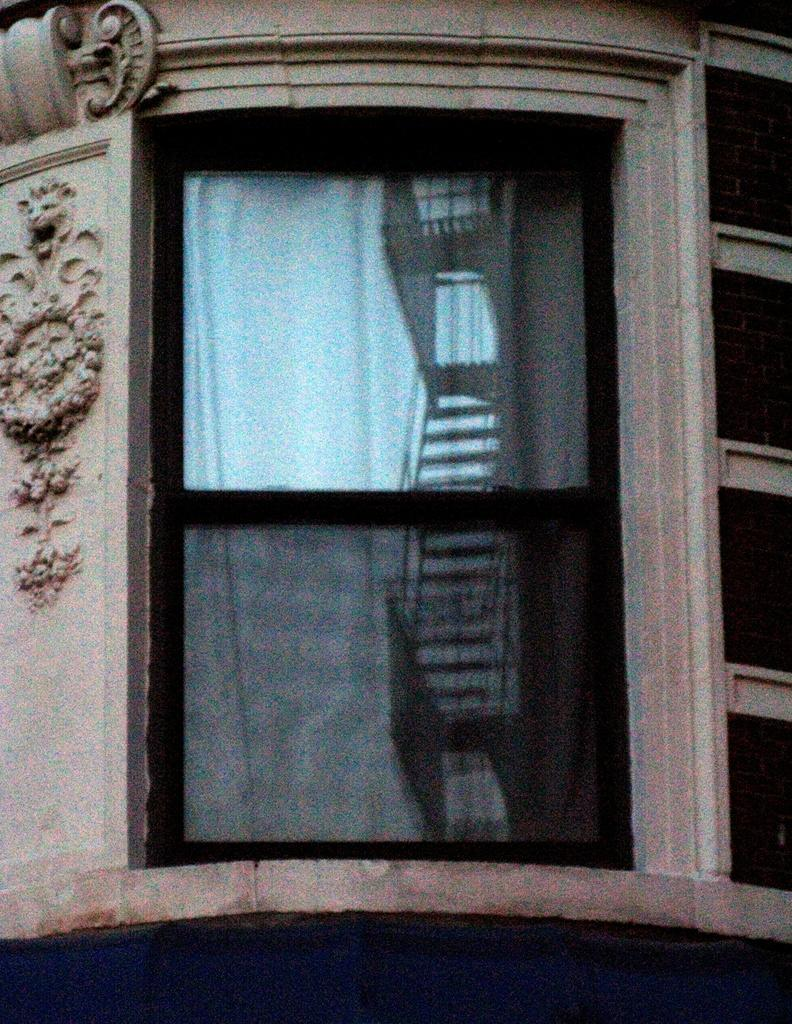What type of structure is present in the image? There is a glass window in the image. How is the glass window connected to the surrounding area? The glass window is attached to a wall. What artistic object can be seen in the image? There is a sculpture in the image. On which side of the image is the sculpture located? The sculpture is on the left side of the image. What position does the giraffe hold in the image? There is no giraffe present in the image. 